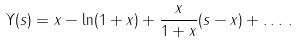<formula> <loc_0><loc_0><loc_500><loc_500>\Upsilon ( s ) = x - \ln ( 1 + x ) + \frac { x } { 1 + x } ( s - x ) + \dots \, .</formula> 